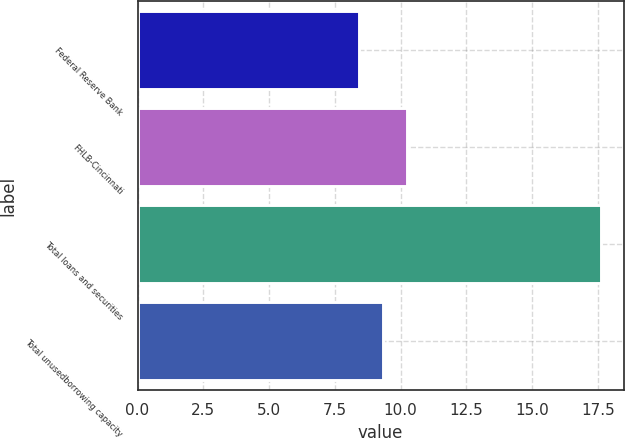Convert chart. <chart><loc_0><loc_0><loc_500><loc_500><bar_chart><fcel>Federal Reserve Bank<fcel>FHLB-Cincinnati<fcel>Total loans and securities<fcel>Total unusedborrowing capacity<nl><fcel>8.4<fcel>10.24<fcel>17.6<fcel>9.32<nl></chart> 